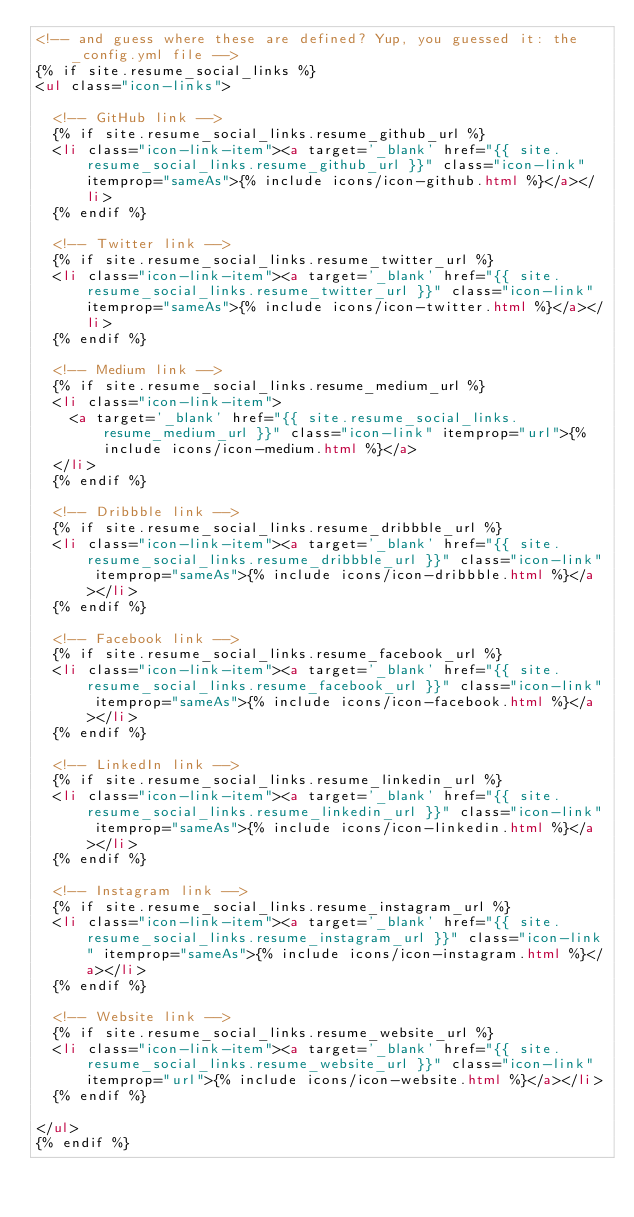<code> <loc_0><loc_0><loc_500><loc_500><_HTML_><!-- and guess where these are defined? Yup, you guessed it: the _config.yml file -->
{% if site.resume_social_links %}
<ul class="icon-links">

  <!-- GitHub link -->
  {% if site.resume_social_links.resume_github_url %}
  <li class="icon-link-item"><a target='_blank' href="{{ site.resume_social_links.resume_github_url }}" class="icon-link" itemprop="sameAs">{% include icons/icon-github.html %}</a></li>
  {% endif %}

  <!-- Twitter link -->
  {% if site.resume_social_links.resume_twitter_url %}
  <li class="icon-link-item"><a target='_blank' href="{{ site.resume_social_links.resume_twitter_url }}" class="icon-link" itemprop="sameAs">{% include icons/icon-twitter.html %}</a></li>
  {% endif %}
  
  <!-- Medium link -->
  {% if site.resume_social_links.resume_medium_url %}
  <li class="icon-link-item">
    <a target='_blank' href="{{ site.resume_social_links.resume_medium_url }}" class="icon-link" itemprop="url">{% include icons/icon-medium.html %}</a>
  </li>
  {% endif %}

  <!-- Dribbble link -->
  {% if site.resume_social_links.resume_dribbble_url %}
  <li class="icon-link-item"><a target='_blank' href="{{ site.resume_social_links.resume_dribbble_url }}" class="icon-link" itemprop="sameAs">{% include icons/icon-dribbble.html %}</a></li>
  {% endif %}

  <!-- Facebook link -->
  {% if site.resume_social_links.resume_facebook_url %}
  <li class="icon-link-item"><a target='_blank' href="{{ site.resume_social_links.resume_facebook_url }}" class="icon-link" itemprop="sameAs">{% include icons/icon-facebook.html %}</a></li>
  {% endif %}

  <!-- LinkedIn link -->
  {% if site.resume_social_links.resume_linkedin_url %}
  <li class="icon-link-item"><a target='_blank' href="{{ site.resume_social_links.resume_linkedin_url }}" class="icon-link" itemprop="sameAs">{% include icons/icon-linkedin.html %}</a></li>
  {% endif %}

  <!-- Instagram link -->
  {% if site.resume_social_links.resume_instagram_url %}
  <li class="icon-link-item"><a target='_blank' href="{{ site.resume_social_links.resume_instagram_url }}" class="icon-link" itemprop="sameAs">{% include icons/icon-instagram.html %}</a></li>
  {% endif %}

  <!-- Website link -->
  {% if site.resume_social_links.resume_website_url %}
  <li class="icon-link-item"><a target='_blank' href="{{ site.resume_social_links.resume_website_url }}" class="icon-link" itemprop="url">{% include icons/icon-website.html %}</a></li>
  {% endif %}

</ul>
{% endif %}
</code> 